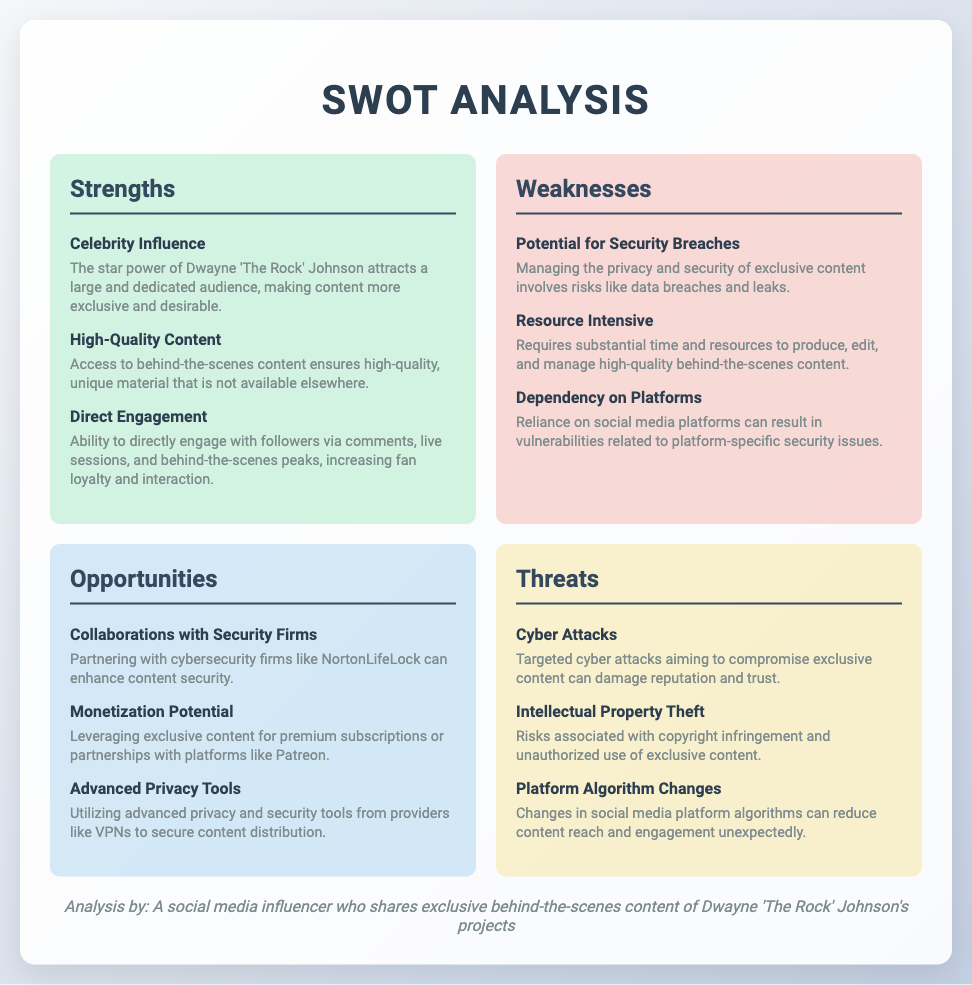What are the strengths listed in the SWOT analysis? The strengths listed in the SWOT analysis include three points about Dwayne 'The Rock' Johnson's projects: Celebrity Influence, High-Quality Content, and Direct Engagement.
Answer: Celebrity Influence, High-Quality Content, Direct Engagement What potential security issue is highlighted in the weaknesses section? The weaknesses section specifically mentions the risk of managing privacy and security leading to potential security breaches.
Answer: Potential for Security Breaches Which opportunity suggests a partnership with cybersecurity firms? The opportunity regarding security states that collaborating with security firms like NortonLifeLock can enhance content security.
Answer: Collaborations with Security Firms What is a listed threat related to social media platforms? The threat section identifies platform algorithm changes as a risk that can unexpectedly reduce content reach and engagement.
Answer: Platform Algorithm Changes How many items are there in the opportunities section? The document lists three items in the opportunities section related to managing privacy and security of exclusive content.
Answer: Three What is the main focus of the SWOT analysis? The main focus of the SWOT analysis is on managing the privacy and security of exclusive content for Dwayne 'The Rock' Johnson's projects.
Answer: Managing Privacy and Security of Exclusive Content What is one weakness that requires substantial resources? One of the weaknesses stated is that producing, editing, and managing high-quality behind-the-scenes content is resource-intensive.
Answer: Resource Intensive What kind of threats does the SWOT analysis mention? The threats outlined in the SWOT analysis include cyber attacks, intellectual property theft, and platform algorithm changes.
Answer: Cyber Attacks, Intellectual Property Theft, Platform Algorithm Changes 